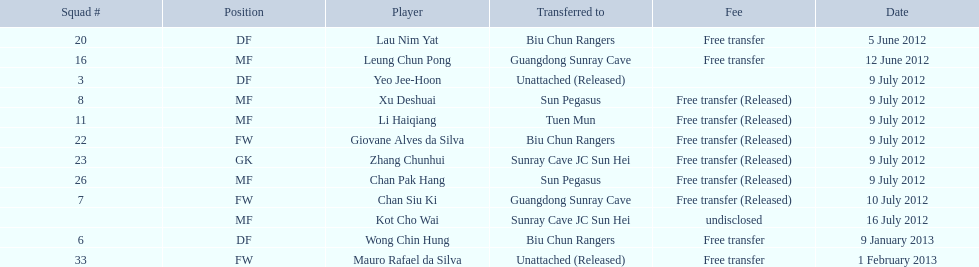Which athletes are mentioned? Lau Nim Yat, Leung Chun Pong, Yeo Jee-Hoon, Xu Deshuai, Li Haiqiang, Giovane Alves da Silva, Zhang Chunhui, Chan Pak Hang, Chan Siu Ki, Kot Cho Wai, Wong Chin Hung, Mauro Rafael da Silva. On what dates did the players join biu chun rangers? 5 June 2012, 9 July 2012, 9 January 2013. Among them, when was wong chin hung transferred? 9 January 2013. Could you help me parse every detail presented in this table? {'header': ['Squad #', 'Position', 'Player', 'Transferred to', 'Fee', 'Date'], 'rows': [['20', 'DF', 'Lau Nim Yat', 'Biu Chun Rangers', 'Free transfer', '5 June 2012'], ['16', 'MF', 'Leung Chun Pong', 'Guangdong Sunray Cave', 'Free transfer', '12 June 2012'], ['3', 'DF', 'Yeo Jee-Hoon', 'Unattached (Released)', '', '9 July 2012'], ['8', 'MF', 'Xu Deshuai', 'Sun Pegasus', 'Free transfer (Released)', '9 July 2012'], ['11', 'MF', 'Li Haiqiang', 'Tuen Mun', 'Free transfer (Released)', '9 July 2012'], ['22', 'FW', 'Giovane Alves da Silva', 'Biu Chun Rangers', 'Free transfer (Released)', '9 July 2012'], ['23', 'GK', 'Zhang Chunhui', 'Sunray Cave JC Sun Hei', 'Free transfer (Released)', '9 July 2012'], ['26', 'MF', 'Chan Pak Hang', 'Sun Pegasus', 'Free transfer (Released)', '9 July 2012'], ['7', 'FW', 'Chan Siu Ki', 'Guangdong Sunray Cave', 'Free transfer (Released)', '10 July 2012'], ['', 'MF', 'Kot Cho Wai', 'Sunray Cave JC Sun Hei', 'undisclosed', '16 July 2012'], ['6', 'DF', 'Wong Chin Hung', 'Biu Chun Rangers', 'Free transfer', '9 January 2013'], ['33', 'FW', 'Mauro Rafael da Silva', 'Unattached (Released)', 'Free transfer', '1 February 2013']]} 